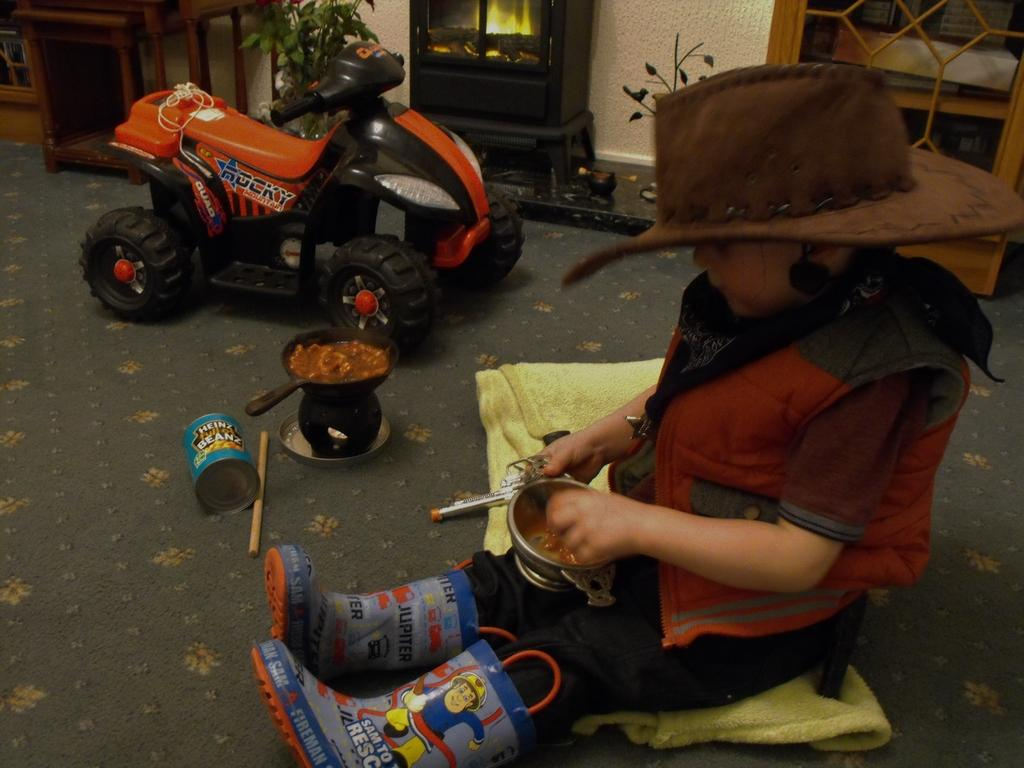Who is the main subject in the image? The main subject in the image is a small boy. Where is the small boy located in the image? The small boy is on the right side of the image. What other object is visible in the image? There is a small bike in the image. Where is the small bike located in the image? The small bike is at the top side of the image. What type of creature is holding the small bike in the image? There is no creature present in the image; the small bike is at the top side of the image. 